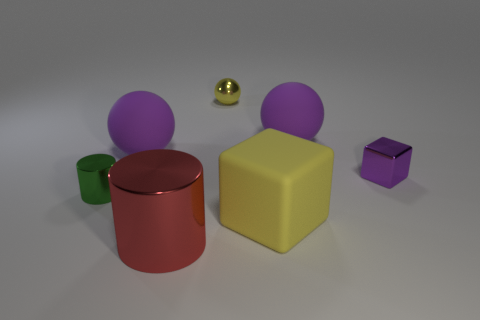Is there a tiny yellow thing made of the same material as the small green thing? While it's difficult to ascertain the materials from a visual examination alone, both the tiny yellow object and the small green object display a reflective surface that suggests they might be made from a similar plastic or metallic material. 